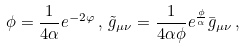Convert formula to latex. <formula><loc_0><loc_0><loc_500><loc_500>\phi = \frac { 1 } { 4 \alpha } e ^ { - 2 \varphi } \, , \, \tilde { g } _ { \mu \nu } = \frac { 1 } { 4 \alpha \phi } e ^ { \frac { \phi } { \alpha } } \bar { g } _ { \mu \nu } \, ,</formula> 